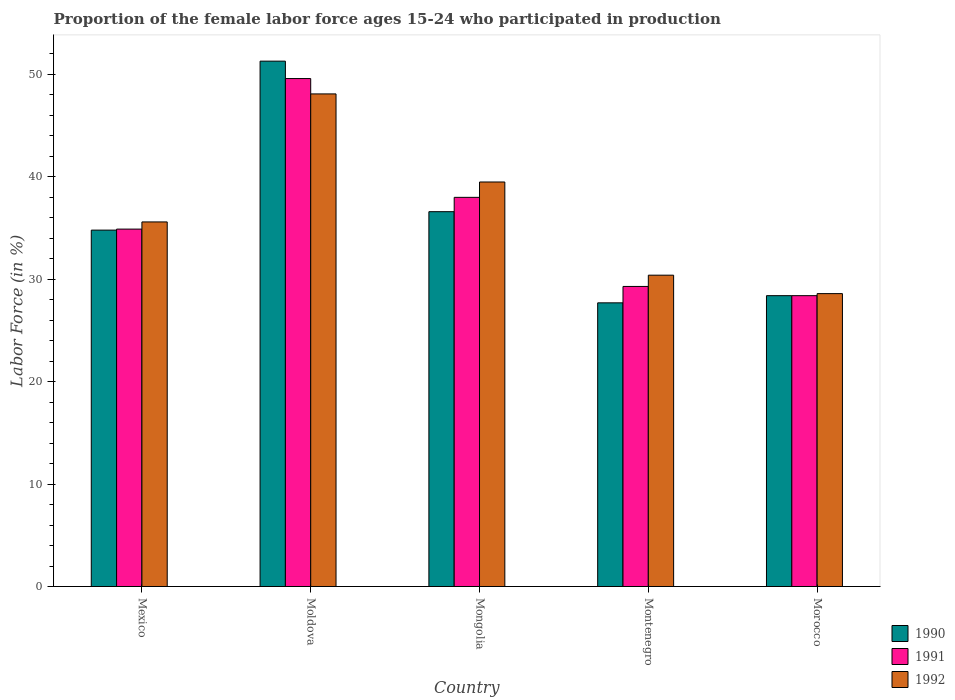How many groups of bars are there?
Make the answer very short. 5. Are the number of bars per tick equal to the number of legend labels?
Provide a short and direct response. Yes. How many bars are there on the 4th tick from the right?
Your answer should be very brief. 3. What is the label of the 4th group of bars from the left?
Provide a succinct answer. Montenegro. What is the proportion of the female labor force who participated in production in 1991 in Montenegro?
Offer a terse response. 29.3. Across all countries, what is the maximum proportion of the female labor force who participated in production in 1992?
Provide a short and direct response. 48.1. Across all countries, what is the minimum proportion of the female labor force who participated in production in 1991?
Provide a short and direct response. 28.4. In which country was the proportion of the female labor force who participated in production in 1990 maximum?
Offer a terse response. Moldova. In which country was the proportion of the female labor force who participated in production in 1992 minimum?
Make the answer very short. Morocco. What is the total proportion of the female labor force who participated in production in 1990 in the graph?
Offer a very short reply. 178.8. What is the difference between the proportion of the female labor force who participated in production in 1992 in Mongolia and that in Morocco?
Your answer should be compact. 10.9. What is the difference between the proportion of the female labor force who participated in production in 1990 in Montenegro and the proportion of the female labor force who participated in production in 1992 in Morocco?
Give a very brief answer. -0.9. What is the average proportion of the female labor force who participated in production in 1992 per country?
Your response must be concise. 36.44. What is the difference between the proportion of the female labor force who participated in production of/in 1990 and proportion of the female labor force who participated in production of/in 1992 in Morocco?
Your answer should be compact. -0.2. In how many countries, is the proportion of the female labor force who participated in production in 1992 greater than 34 %?
Provide a short and direct response. 3. What is the ratio of the proportion of the female labor force who participated in production in 1990 in Mexico to that in Montenegro?
Your response must be concise. 1.26. Is the difference between the proportion of the female labor force who participated in production in 1990 in Montenegro and Morocco greater than the difference between the proportion of the female labor force who participated in production in 1992 in Montenegro and Morocco?
Make the answer very short. No. What is the difference between the highest and the second highest proportion of the female labor force who participated in production in 1992?
Give a very brief answer. 12.5. What is the difference between the highest and the lowest proportion of the female labor force who participated in production in 1990?
Give a very brief answer. 23.6. Is it the case that in every country, the sum of the proportion of the female labor force who participated in production in 1990 and proportion of the female labor force who participated in production in 1992 is greater than the proportion of the female labor force who participated in production in 1991?
Your answer should be compact. Yes. Are all the bars in the graph horizontal?
Your answer should be compact. No. Are the values on the major ticks of Y-axis written in scientific E-notation?
Give a very brief answer. No. How are the legend labels stacked?
Your answer should be compact. Vertical. What is the title of the graph?
Your response must be concise. Proportion of the female labor force ages 15-24 who participated in production. What is the label or title of the X-axis?
Provide a short and direct response. Country. What is the label or title of the Y-axis?
Keep it short and to the point. Labor Force (in %). What is the Labor Force (in %) in 1990 in Mexico?
Make the answer very short. 34.8. What is the Labor Force (in %) of 1991 in Mexico?
Make the answer very short. 34.9. What is the Labor Force (in %) of 1992 in Mexico?
Your response must be concise. 35.6. What is the Labor Force (in %) of 1990 in Moldova?
Ensure brevity in your answer.  51.3. What is the Labor Force (in %) in 1991 in Moldova?
Offer a terse response. 49.6. What is the Labor Force (in %) of 1992 in Moldova?
Give a very brief answer. 48.1. What is the Labor Force (in %) of 1990 in Mongolia?
Give a very brief answer. 36.6. What is the Labor Force (in %) in 1991 in Mongolia?
Provide a short and direct response. 38. What is the Labor Force (in %) in 1992 in Mongolia?
Your answer should be compact. 39.5. What is the Labor Force (in %) of 1990 in Montenegro?
Offer a terse response. 27.7. What is the Labor Force (in %) of 1991 in Montenegro?
Provide a succinct answer. 29.3. What is the Labor Force (in %) in 1992 in Montenegro?
Keep it short and to the point. 30.4. What is the Labor Force (in %) of 1990 in Morocco?
Provide a succinct answer. 28.4. What is the Labor Force (in %) of 1991 in Morocco?
Your answer should be compact. 28.4. What is the Labor Force (in %) of 1992 in Morocco?
Offer a very short reply. 28.6. Across all countries, what is the maximum Labor Force (in %) in 1990?
Keep it short and to the point. 51.3. Across all countries, what is the maximum Labor Force (in %) of 1991?
Your response must be concise. 49.6. Across all countries, what is the maximum Labor Force (in %) in 1992?
Ensure brevity in your answer.  48.1. Across all countries, what is the minimum Labor Force (in %) in 1990?
Give a very brief answer. 27.7. Across all countries, what is the minimum Labor Force (in %) of 1991?
Your answer should be compact. 28.4. Across all countries, what is the minimum Labor Force (in %) of 1992?
Offer a terse response. 28.6. What is the total Labor Force (in %) in 1990 in the graph?
Provide a short and direct response. 178.8. What is the total Labor Force (in %) of 1991 in the graph?
Your response must be concise. 180.2. What is the total Labor Force (in %) of 1992 in the graph?
Your response must be concise. 182.2. What is the difference between the Labor Force (in %) of 1990 in Mexico and that in Moldova?
Offer a very short reply. -16.5. What is the difference between the Labor Force (in %) in 1991 in Mexico and that in Moldova?
Ensure brevity in your answer.  -14.7. What is the difference between the Labor Force (in %) in 1990 in Mexico and that in Mongolia?
Offer a very short reply. -1.8. What is the difference between the Labor Force (in %) of 1991 in Mexico and that in Mongolia?
Offer a very short reply. -3.1. What is the difference between the Labor Force (in %) of 1990 in Mexico and that in Montenegro?
Provide a succinct answer. 7.1. What is the difference between the Labor Force (in %) in 1992 in Mexico and that in Montenegro?
Ensure brevity in your answer.  5.2. What is the difference between the Labor Force (in %) in 1992 in Mexico and that in Morocco?
Your answer should be compact. 7. What is the difference between the Labor Force (in %) in 1990 in Moldova and that in Mongolia?
Provide a short and direct response. 14.7. What is the difference between the Labor Force (in %) in 1991 in Moldova and that in Mongolia?
Your answer should be compact. 11.6. What is the difference between the Labor Force (in %) in 1990 in Moldova and that in Montenegro?
Provide a short and direct response. 23.6. What is the difference between the Labor Force (in %) in 1991 in Moldova and that in Montenegro?
Give a very brief answer. 20.3. What is the difference between the Labor Force (in %) of 1992 in Moldova and that in Montenegro?
Ensure brevity in your answer.  17.7. What is the difference between the Labor Force (in %) of 1990 in Moldova and that in Morocco?
Your answer should be compact. 22.9. What is the difference between the Labor Force (in %) of 1991 in Moldova and that in Morocco?
Ensure brevity in your answer.  21.2. What is the difference between the Labor Force (in %) of 1992 in Moldova and that in Morocco?
Offer a terse response. 19.5. What is the difference between the Labor Force (in %) of 1991 in Mongolia and that in Morocco?
Ensure brevity in your answer.  9.6. What is the difference between the Labor Force (in %) of 1990 in Montenegro and that in Morocco?
Provide a short and direct response. -0.7. What is the difference between the Labor Force (in %) in 1990 in Mexico and the Labor Force (in %) in 1991 in Moldova?
Make the answer very short. -14.8. What is the difference between the Labor Force (in %) of 1990 in Mexico and the Labor Force (in %) of 1992 in Moldova?
Provide a short and direct response. -13.3. What is the difference between the Labor Force (in %) of 1990 in Mexico and the Labor Force (in %) of 1991 in Montenegro?
Your answer should be compact. 5.5. What is the difference between the Labor Force (in %) of 1990 in Mexico and the Labor Force (in %) of 1992 in Montenegro?
Keep it short and to the point. 4.4. What is the difference between the Labor Force (in %) of 1991 in Mexico and the Labor Force (in %) of 1992 in Montenegro?
Make the answer very short. 4.5. What is the difference between the Labor Force (in %) of 1991 in Mexico and the Labor Force (in %) of 1992 in Morocco?
Ensure brevity in your answer.  6.3. What is the difference between the Labor Force (in %) of 1990 in Moldova and the Labor Force (in %) of 1991 in Mongolia?
Your response must be concise. 13.3. What is the difference between the Labor Force (in %) in 1991 in Moldova and the Labor Force (in %) in 1992 in Mongolia?
Your answer should be very brief. 10.1. What is the difference between the Labor Force (in %) of 1990 in Moldova and the Labor Force (in %) of 1991 in Montenegro?
Offer a terse response. 22. What is the difference between the Labor Force (in %) of 1990 in Moldova and the Labor Force (in %) of 1992 in Montenegro?
Ensure brevity in your answer.  20.9. What is the difference between the Labor Force (in %) in 1991 in Moldova and the Labor Force (in %) in 1992 in Montenegro?
Your answer should be very brief. 19.2. What is the difference between the Labor Force (in %) in 1990 in Moldova and the Labor Force (in %) in 1991 in Morocco?
Your answer should be very brief. 22.9. What is the difference between the Labor Force (in %) in 1990 in Moldova and the Labor Force (in %) in 1992 in Morocco?
Give a very brief answer. 22.7. What is the difference between the Labor Force (in %) in 1990 in Mongolia and the Labor Force (in %) in 1991 in Montenegro?
Your response must be concise. 7.3. What is the difference between the Labor Force (in %) of 1990 in Mongolia and the Labor Force (in %) of 1992 in Montenegro?
Your answer should be very brief. 6.2. What is the difference between the Labor Force (in %) in 1990 in Mongolia and the Labor Force (in %) in 1991 in Morocco?
Provide a succinct answer. 8.2. What is the difference between the Labor Force (in %) in 1990 in Montenegro and the Labor Force (in %) in 1991 in Morocco?
Make the answer very short. -0.7. What is the difference between the Labor Force (in %) in 1990 in Montenegro and the Labor Force (in %) in 1992 in Morocco?
Your response must be concise. -0.9. What is the average Labor Force (in %) in 1990 per country?
Provide a short and direct response. 35.76. What is the average Labor Force (in %) in 1991 per country?
Offer a terse response. 36.04. What is the average Labor Force (in %) in 1992 per country?
Ensure brevity in your answer.  36.44. What is the difference between the Labor Force (in %) in 1990 and Labor Force (in %) in 1992 in Mexico?
Your answer should be compact. -0.8. What is the difference between the Labor Force (in %) in 1991 and Labor Force (in %) in 1992 in Mexico?
Your answer should be compact. -0.7. What is the difference between the Labor Force (in %) in 1991 and Labor Force (in %) in 1992 in Moldova?
Your answer should be very brief. 1.5. What is the difference between the Labor Force (in %) of 1991 and Labor Force (in %) of 1992 in Mongolia?
Ensure brevity in your answer.  -1.5. What is the difference between the Labor Force (in %) in 1990 and Labor Force (in %) in 1992 in Montenegro?
Offer a very short reply. -2.7. What is the difference between the Labor Force (in %) of 1991 and Labor Force (in %) of 1992 in Montenegro?
Provide a succinct answer. -1.1. What is the difference between the Labor Force (in %) of 1990 and Labor Force (in %) of 1991 in Morocco?
Provide a short and direct response. 0. What is the difference between the Labor Force (in %) of 1990 and Labor Force (in %) of 1992 in Morocco?
Provide a succinct answer. -0.2. What is the difference between the Labor Force (in %) in 1991 and Labor Force (in %) in 1992 in Morocco?
Keep it short and to the point. -0.2. What is the ratio of the Labor Force (in %) in 1990 in Mexico to that in Moldova?
Your response must be concise. 0.68. What is the ratio of the Labor Force (in %) in 1991 in Mexico to that in Moldova?
Your answer should be compact. 0.7. What is the ratio of the Labor Force (in %) of 1992 in Mexico to that in Moldova?
Your answer should be very brief. 0.74. What is the ratio of the Labor Force (in %) in 1990 in Mexico to that in Mongolia?
Your answer should be very brief. 0.95. What is the ratio of the Labor Force (in %) in 1991 in Mexico to that in Mongolia?
Your response must be concise. 0.92. What is the ratio of the Labor Force (in %) in 1992 in Mexico to that in Mongolia?
Offer a very short reply. 0.9. What is the ratio of the Labor Force (in %) of 1990 in Mexico to that in Montenegro?
Provide a short and direct response. 1.26. What is the ratio of the Labor Force (in %) of 1991 in Mexico to that in Montenegro?
Keep it short and to the point. 1.19. What is the ratio of the Labor Force (in %) of 1992 in Mexico to that in Montenegro?
Offer a very short reply. 1.17. What is the ratio of the Labor Force (in %) in 1990 in Mexico to that in Morocco?
Your answer should be compact. 1.23. What is the ratio of the Labor Force (in %) of 1991 in Mexico to that in Morocco?
Keep it short and to the point. 1.23. What is the ratio of the Labor Force (in %) in 1992 in Mexico to that in Morocco?
Your response must be concise. 1.24. What is the ratio of the Labor Force (in %) of 1990 in Moldova to that in Mongolia?
Provide a succinct answer. 1.4. What is the ratio of the Labor Force (in %) in 1991 in Moldova to that in Mongolia?
Your answer should be very brief. 1.31. What is the ratio of the Labor Force (in %) in 1992 in Moldova to that in Mongolia?
Keep it short and to the point. 1.22. What is the ratio of the Labor Force (in %) in 1990 in Moldova to that in Montenegro?
Offer a very short reply. 1.85. What is the ratio of the Labor Force (in %) in 1991 in Moldova to that in Montenegro?
Give a very brief answer. 1.69. What is the ratio of the Labor Force (in %) of 1992 in Moldova to that in Montenegro?
Provide a short and direct response. 1.58. What is the ratio of the Labor Force (in %) in 1990 in Moldova to that in Morocco?
Make the answer very short. 1.81. What is the ratio of the Labor Force (in %) in 1991 in Moldova to that in Morocco?
Provide a succinct answer. 1.75. What is the ratio of the Labor Force (in %) in 1992 in Moldova to that in Morocco?
Make the answer very short. 1.68. What is the ratio of the Labor Force (in %) of 1990 in Mongolia to that in Montenegro?
Your answer should be very brief. 1.32. What is the ratio of the Labor Force (in %) in 1991 in Mongolia to that in Montenegro?
Give a very brief answer. 1.3. What is the ratio of the Labor Force (in %) in 1992 in Mongolia to that in Montenegro?
Offer a terse response. 1.3. What is the ratio of the Labor Force (in %) in 1990 in Mongolia to that in Morocco?
Your answer should be very brief. 1.29. What is the ratio of the Labor Force (in %) of 1991 in Mongolia to that in Morocco?
Ensure brevity in your answer.  1.34. What is the ratio of the Labor Force (in %) of 1992 in Mongolia to that in Morocco?
Provide a short and direct response. 1.38. What is the ratio of the Labor Force (in %) in 1990 in Montenegro to that in Morocco?
Provide a short and direct response. 0.98. What is the ratio of the Labor Force (in %) in 1991 in Montenegro to that in Morocco?
Offer a very short reply. 1.03. What is the ratio of the Labor Force (in %) of 1992 in Montenegro to that in Morocco?
Offer a terse response. 1.06. What is the difference between the highest and the second highest Labor Force (in %) of 1990?
Your answer should be very brief. 14.7. What is the difference between the highest and the second highest Labor Force (in %) of 1991?
Your answer should be compact. 11.6. What is the difference between the highest and the lowest Labor Force (in %) of 1990?
Your answer should be very brief. 23.6. What is the difference between the highest and the lowest Labor Force (in %) in 1991?
Ensure brevity in your answer.  21.2. 